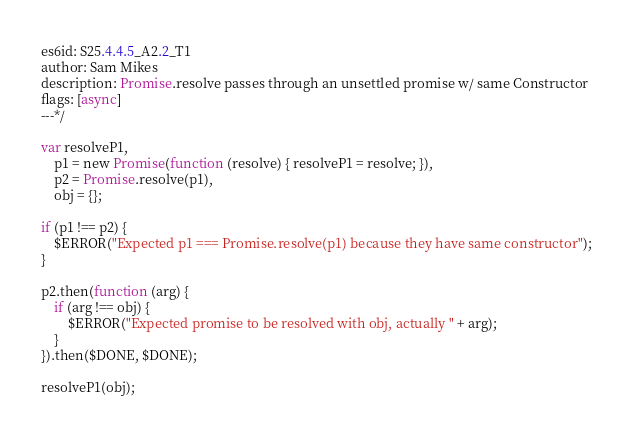<code> <loc_0><loc_0><loc_500><loc_500><_JavaScript_>es6id: S25.4.4.5_A2.2_T1
author: Sam Mikes
description: Promise.resolve passes through an unsettled promise w/ same Constructor
flags: [async]
---*/

var resolveP1,
    p1 = new Promise(function (resolve) { resolveP1 = resolve; }),
    p2 = Promise.resolve(p1),
    obj = {};

if (p1 !== p2) {
    $ERROR("Expected p1 === Promise.resolve(p1) because they have same constructor");
}

p2.then(function (arg) {
    if (arg !== obj) {
        $ERROR("Expected promise to be resolved with obj, actually " + arg);
    }
}).then($DONE, $DONE);

resolveP1(obj);
</code> 